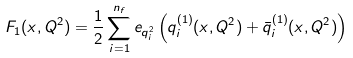<formula> <loc_0><loc_0><loc_500><loc_500>F _ { 1 } ( x , Q ^ { 2 } ) = { \frac { 1 } { 2 } } \sum _ { i = 1 } ^ { n _ { f } } e _ { q _ { i } ^ { 2 } } \left ( q _ { i } ^ { ( 1 ) } ( x , Q ^ { 2 } ) + { \bar { q } } _ { i } ^ { ( 1 ) } ( x , Q ^ { 2 } ) \right )</formula> 